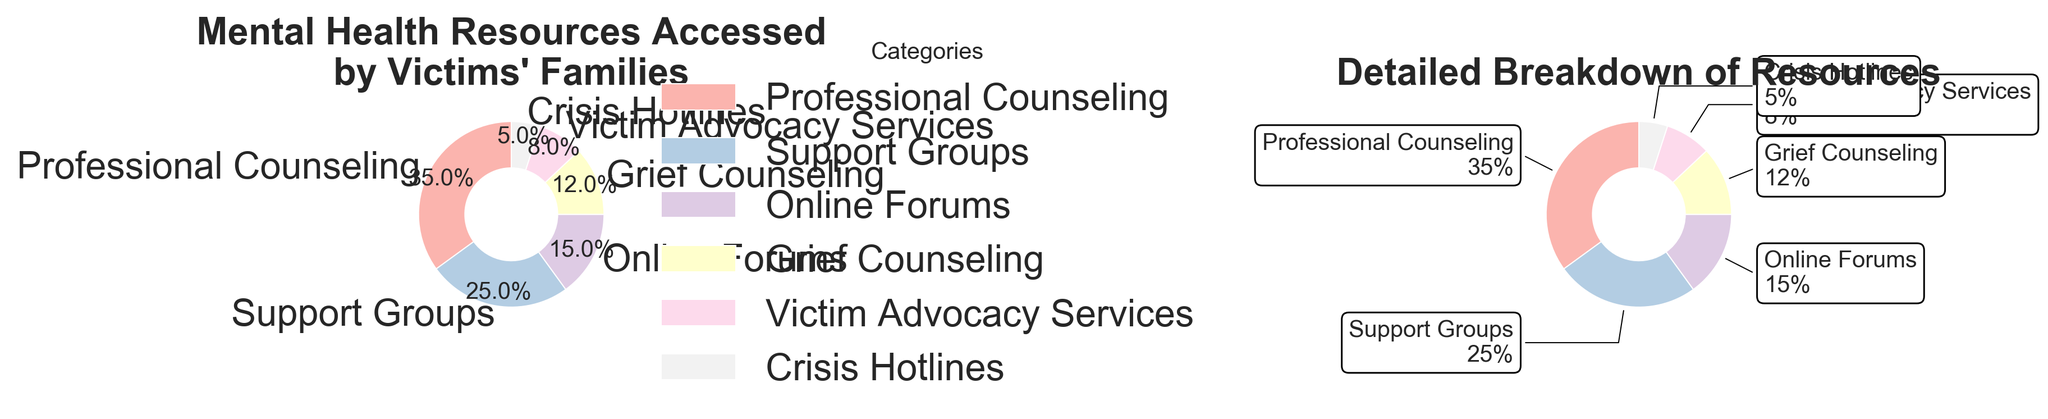What is the title of the first pie chart? The title of the first pie chart can be found at the top of the chart. It reads, "Mental Health Resources Accessed by Victims' Families."
Answer: "Mental Health Resources Accessed by Victims' Families" What percentage of victims' families accessed Professional Counseling? The first pie chart shows different categories along with their percentages. From the chart, we can see that Professional Counseling has a percentage of 35.
Answer: 35% What is the combined percentage of families who accessed Online Forums and Grief Counseling? To find the combined percentage, sum the percentages for Online Forums (15) and Grief Counseling (12). 15 + 12 = 27
Answer: 27% Which mental health resource has the smallest percentage of access by victims' families? The smallest percentage is 5%, which corresponds to Crisis Hotlines in both charts.
Answer: Crisis Hotlines How many categories are represented in the pie charts? The pie charts show one segment per category. By counting the segments, it's clear there are 6 categories.
Answer: 6 Which categories are shown in both pie charts? Both pie charts display the same categories. By looking at the labels, we identify Professional Counseling, Support Groups, Online Forums, Grief Counseling, Victim Advocacy Services, and Crisis Hotlines.
Answer: Professional Counseling, Support Groups, Online Forums, Grief Counseling, Victim Advocacy Services, Crisis Hotlines How much larger is the percentage of families accessing Professional Counseling compared to Crisis Hotlines? To find the difference, subtract the percentage of Crisis Hotlines (5) from Professional Counseling (35). 35 - 5 = 30
Answer: 30% Which category appears next to Professional Counseling in the second donut chart? By observing the position of the segments and their labels, we see that Support Groups is adjacent to Professional Counseling in the second donut chart.
Answer: Support Groups What is the percentage difference between Support Groups and Victim Advocacy Services? Subtract the percentage of Victim Advocacy Services (8) from Support Groups (25). 25 - 8 = 17
Answer: 17% What does the center circle in the second donut chart represent? The center circle in a donut chart is typically used to create a hole in the middle for aesthetic purposes or to place information. Here, it makes the chart look like a donut.
Answer: Aesthetics/Design 